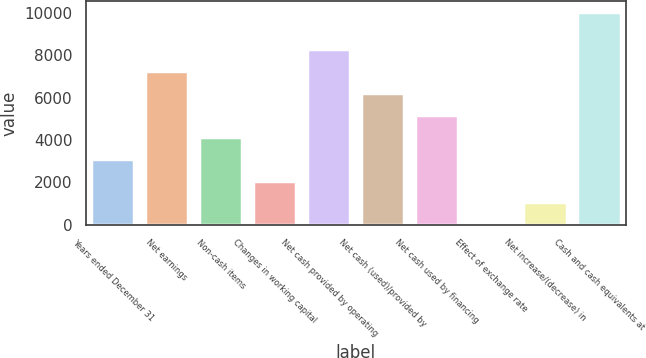Convert chart. <chart><loc_0><loc_0><loc_500><loc_500><bar_chart><fcel>Years ended December 31<fcel>Net earnings<fcel>Non-cash items<fcel>Changes in working capital<fcel>Net cash provided by operating<fcel>Net cash (used)/provided by<fcel>Net cash used by financing<fcel>Effect of exchange rate<fcel>Net increase/(decrease) in<fcel>Cash and cash equivalents at<nl><fcel>3114.9<fcel>7244.1<fcel>4147.2<fcel>2082.6<fcel>8276.4<fcel>6211.8<fcel>5179.5<fcel>18<fcel>1050.3<fcel>10049<nl></chart> 